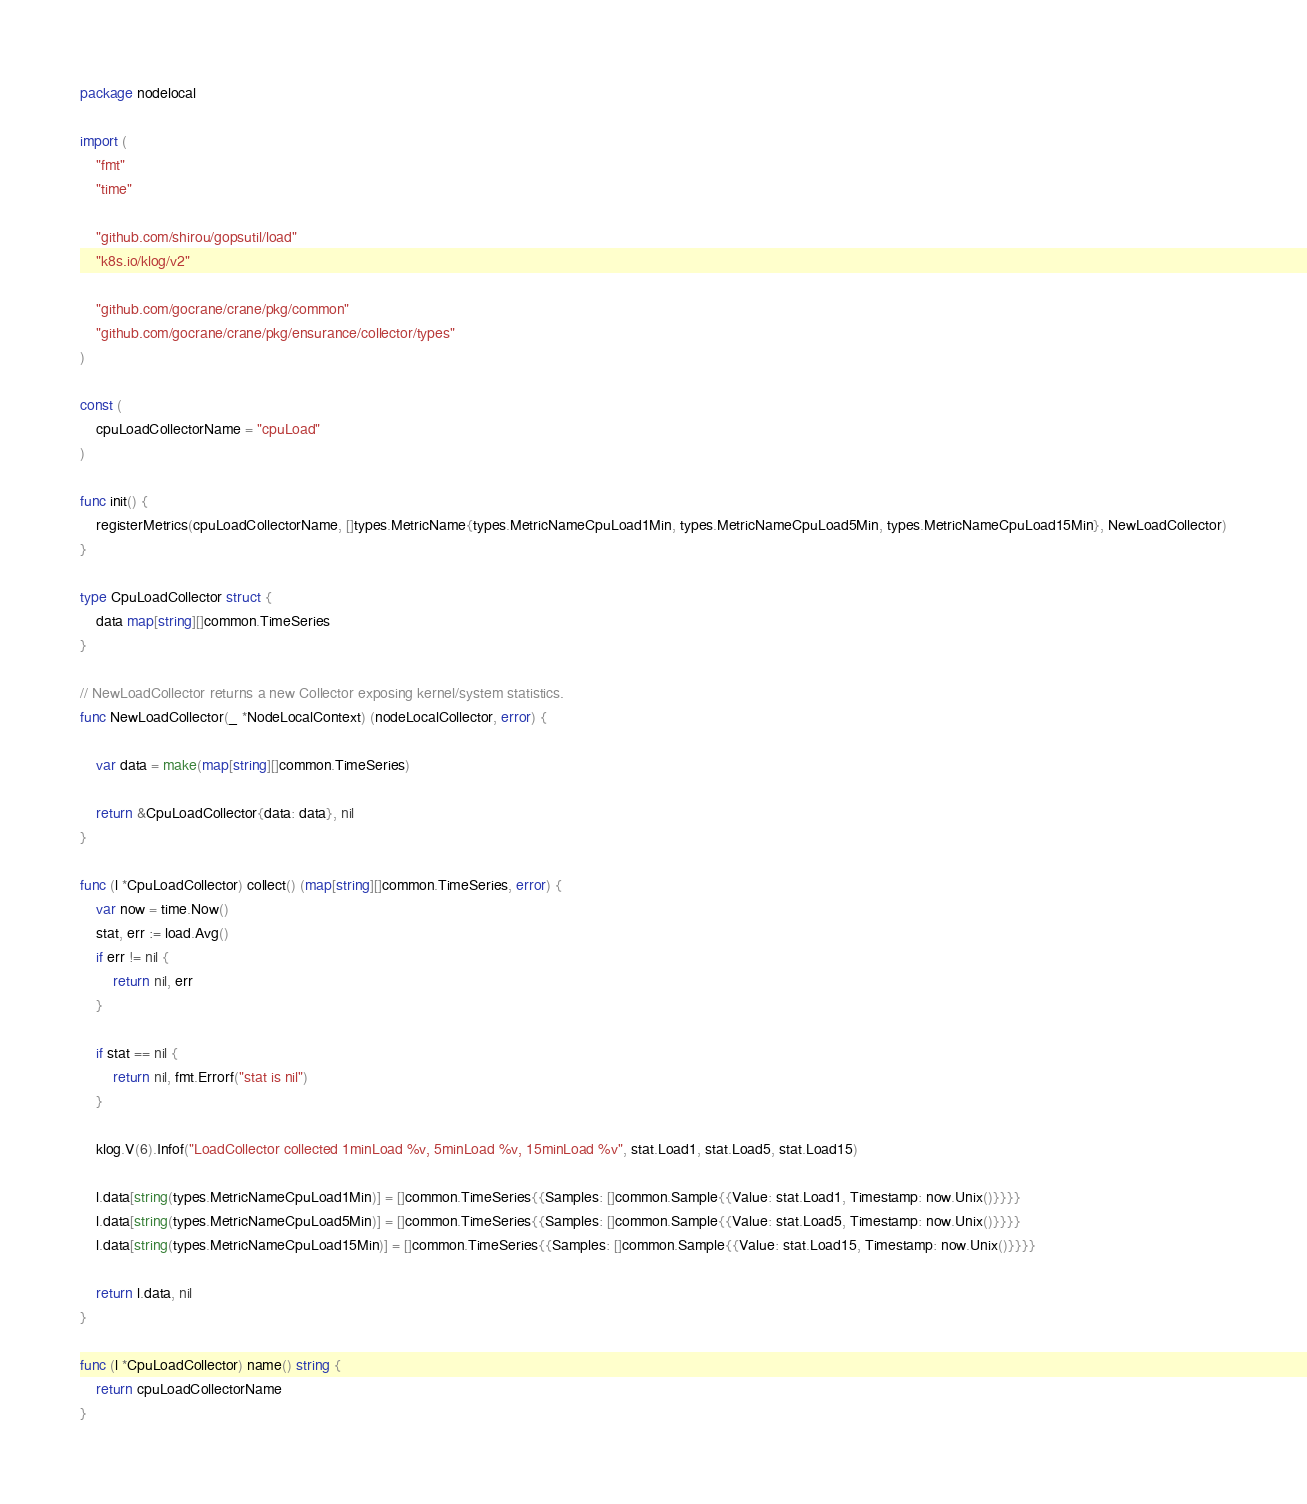<code> <loc_0><loc_0><loc_500><loc_500><_Go_>package nodelocal

import (
	"fmt"
	"time"

	"github.com/shirou/gopsutil/load"
	"k8s.io/klog/v2"

	"github.com/gocrane/crane/pkg/common"
	"github.com/gocrane/crane/pkg/ensurance/collector/types"
)

const (
	cpuLoadCollectorName = "cpuLoad"
)

func init() {
	registerMetrics(cpuLoadCollectorName, []types.MetricName{types.MetricNameCpuLoad1Min, types.MetricNameCpuLoad5Min, types.MetricNameCpuLoad15Min}, NewLoadCollector)
}

type CpuLoadCollector struct {
	data map[string][]common.TimeSeries
}

// NewLoadCollector returns a new Collector exposing kernel/system statistics.
func NewLoadCollector(_ *NodeLocalContext) (nodeLocalCollector, error) {

	var data = make(map[string][]common.TimeSeries)

	return &CpuLoadCollector{data: data}, nil
}

func (l *CpuLoadCollector) collect() (map[string][]common.TimeSeries, error) {
	var now = time.Now()
	stat, err := load.Avg()
	if err != nil {
		return nil, err
	}

	if stat == nil {
		return nil, fmt.Errorf("stat is nil")
	}

	klog.V(6).Infof("LoadCollector collected 1minLoad %v, 5minLoad %v, 15minLoad %v", stat.Load1, stat.Load5, stat.Load15)

	l.data[string(types.MetricNameCpuLoad1Min)] = []common.TimeSeries{{Samples: []common.Sample{{Value: stat.Load1, Timestamp: now.Unix()}}}}
	l.data[string(types.MetricNameCpuLoad5Min)] = []common.TimeSeries{{Samples: []common.Sample{{Value: stat.Load5, Timestamp: now.Unix()}}}}
	l.data[string(types.MetricNameCpuLoad15Min)] = []common.TimeSeries{{Samples: []common.Sample{{Value: stat.Load15, Timestamp: now.Unix()}}}}

	return l.data, nil
}

func (l *CpuLoadCollector) name() string {
	return cpuLoadCollectorName
}
</code> 